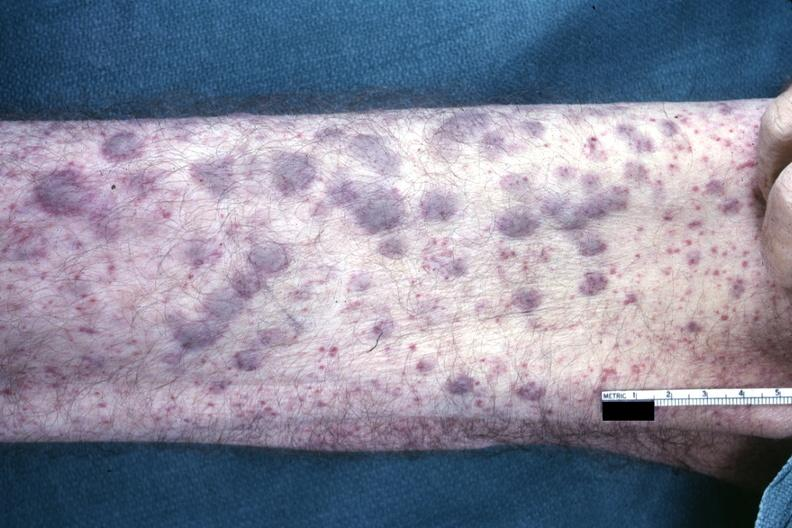where is this?
Answer the question using a single word or phrase. Skin 